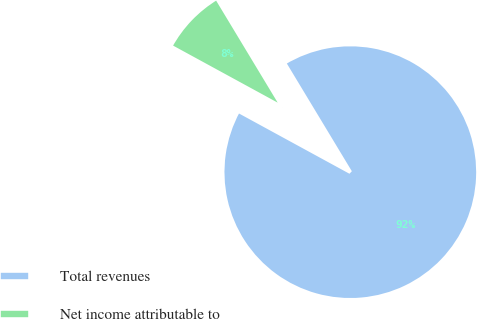Convert chart to OTSL. <chart><loc_0><loc_0><loc_500><loc_500><pie_chart><fcel>Total revenues<fcel>Net income attributable to<nl><fcel>91.59%<fcel>8.41%<nl></chart> 